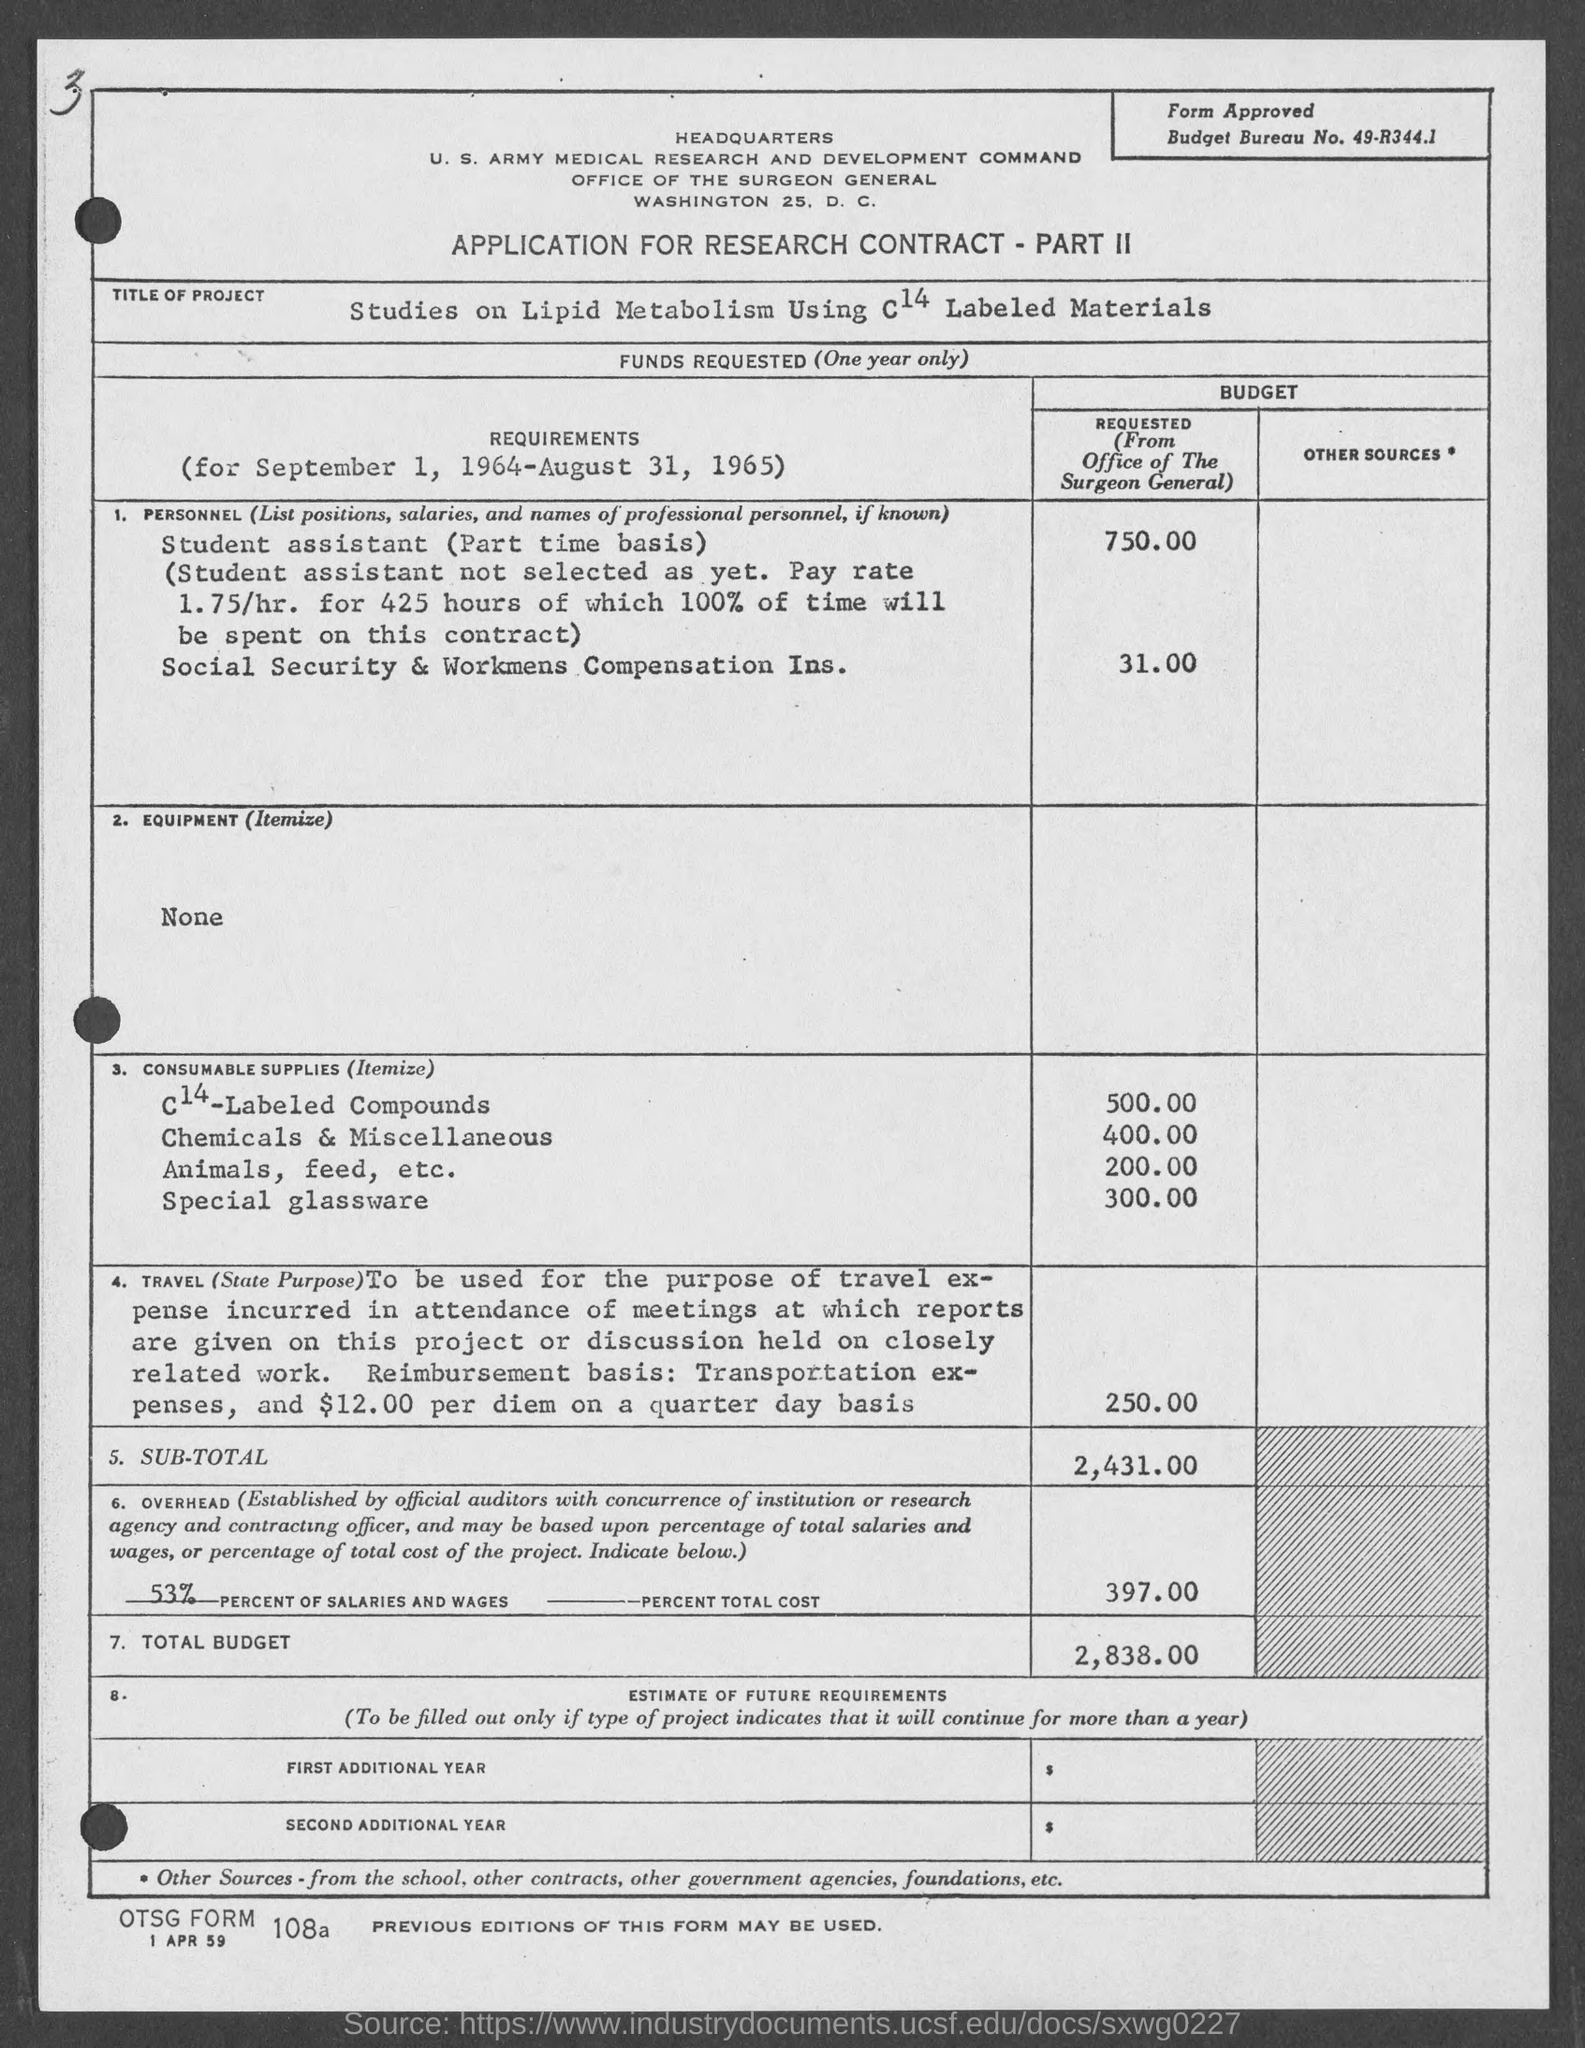Draw attention to some important aspects in this diagram. The amount for C14-labeled compounds, as stated in the given form, is 500.00. The amount for special glassware, as specified in the provided form, is 300.00. The amount for animals, feed, and other related expenses mentioned in the provided form is 200.00. The information given in the provided page states that the percent of salaries and wages is 53%. The total budget mentioned in the given page is 2,838.00. 